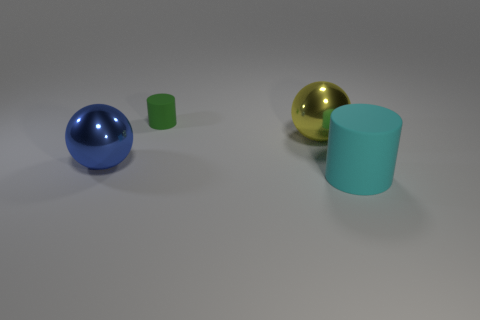Add 2 big gray metallic blocks. How many objects exist? 6 Subtract all big brown metal balls. Subtract all tiny green matte objects. How many objects are left? 3 Add 2 tiny green rubber cylinders. How many tiny green rubber cylinders are left? 3 Add 4 tiny cylinders. How many tiny cylinders exist? 5 Subtract 0 green blocks. How many objects are left? 4 